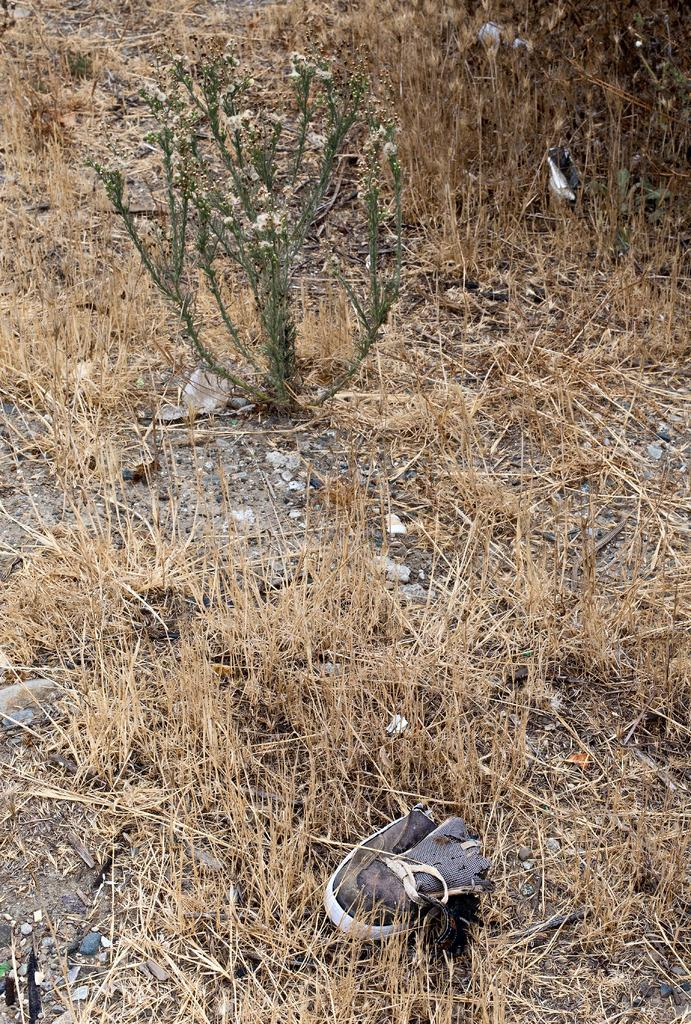Where was the image taken? The image was clicked outside. What can be seen on the ground in the image? There is an object lying on the ground in the image. What type of vegetation is visible in the image? Dry stems are visible in the image. What type of plant is present in the image? There is a plant in the image. What arithmetic problem is being solved by the plant in the image? There is no arithmetic problem being solved by the plant in the image; it is a living organism and not capable of solving mathematical problems. 